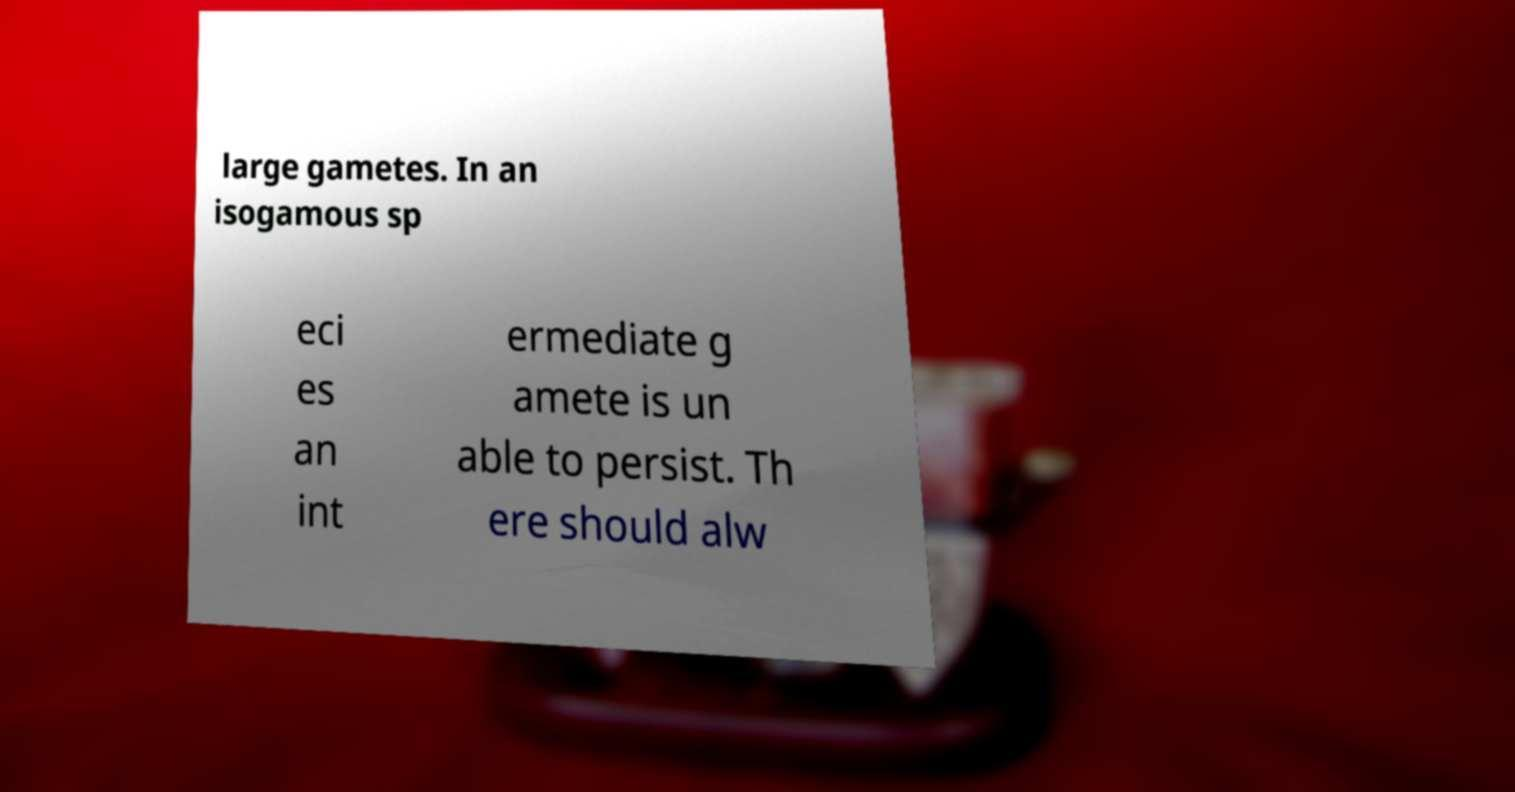There's text embedded in this image that I need extracted. Can you transcribe it verbatim? large gametes. In an isogamous sp eci es an int ermediate g amete is un able to persist. Th ere should alw 